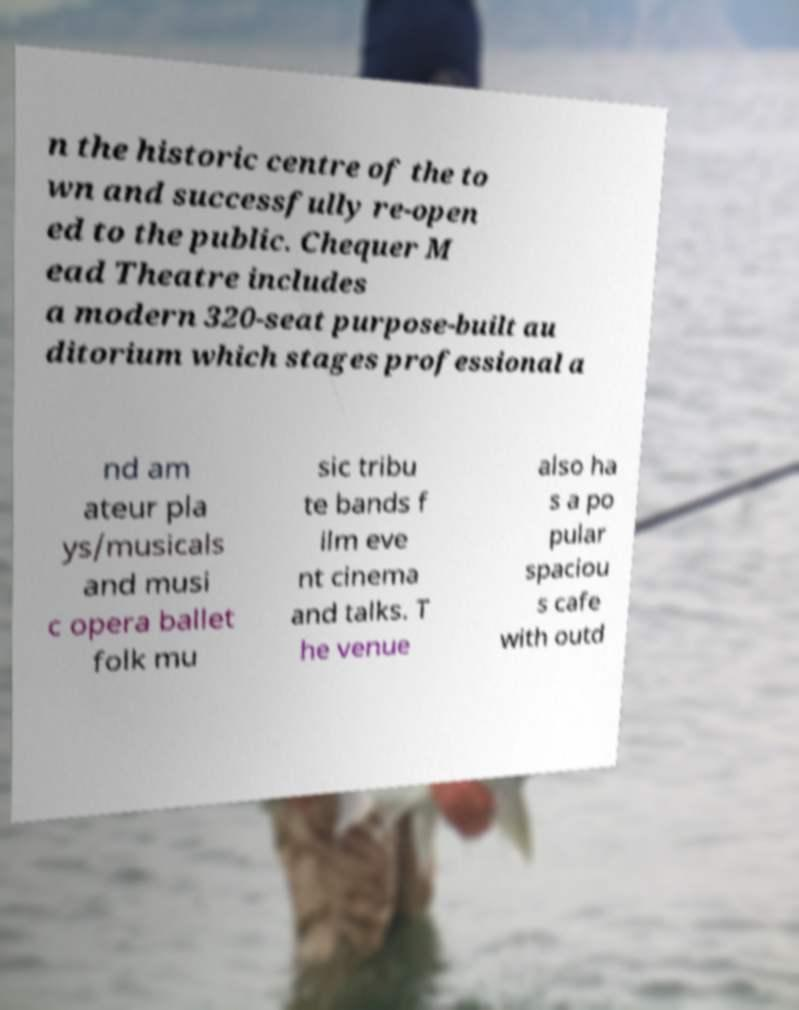Can you accurately transcribe the text from the provided image for me? n the historic centre of the to wn and successfully re-open ed to the public. Chequer M ead Theatre includes a modern 320-seat purpose-built au ditorium which stages professional a nd am ateur pla ys/musicals and musi c opera ballet folk mu sic tribu te bands f ilm eve nt cinema and talks. T he venue also ha s a po pular spaciou s cafe with outd 